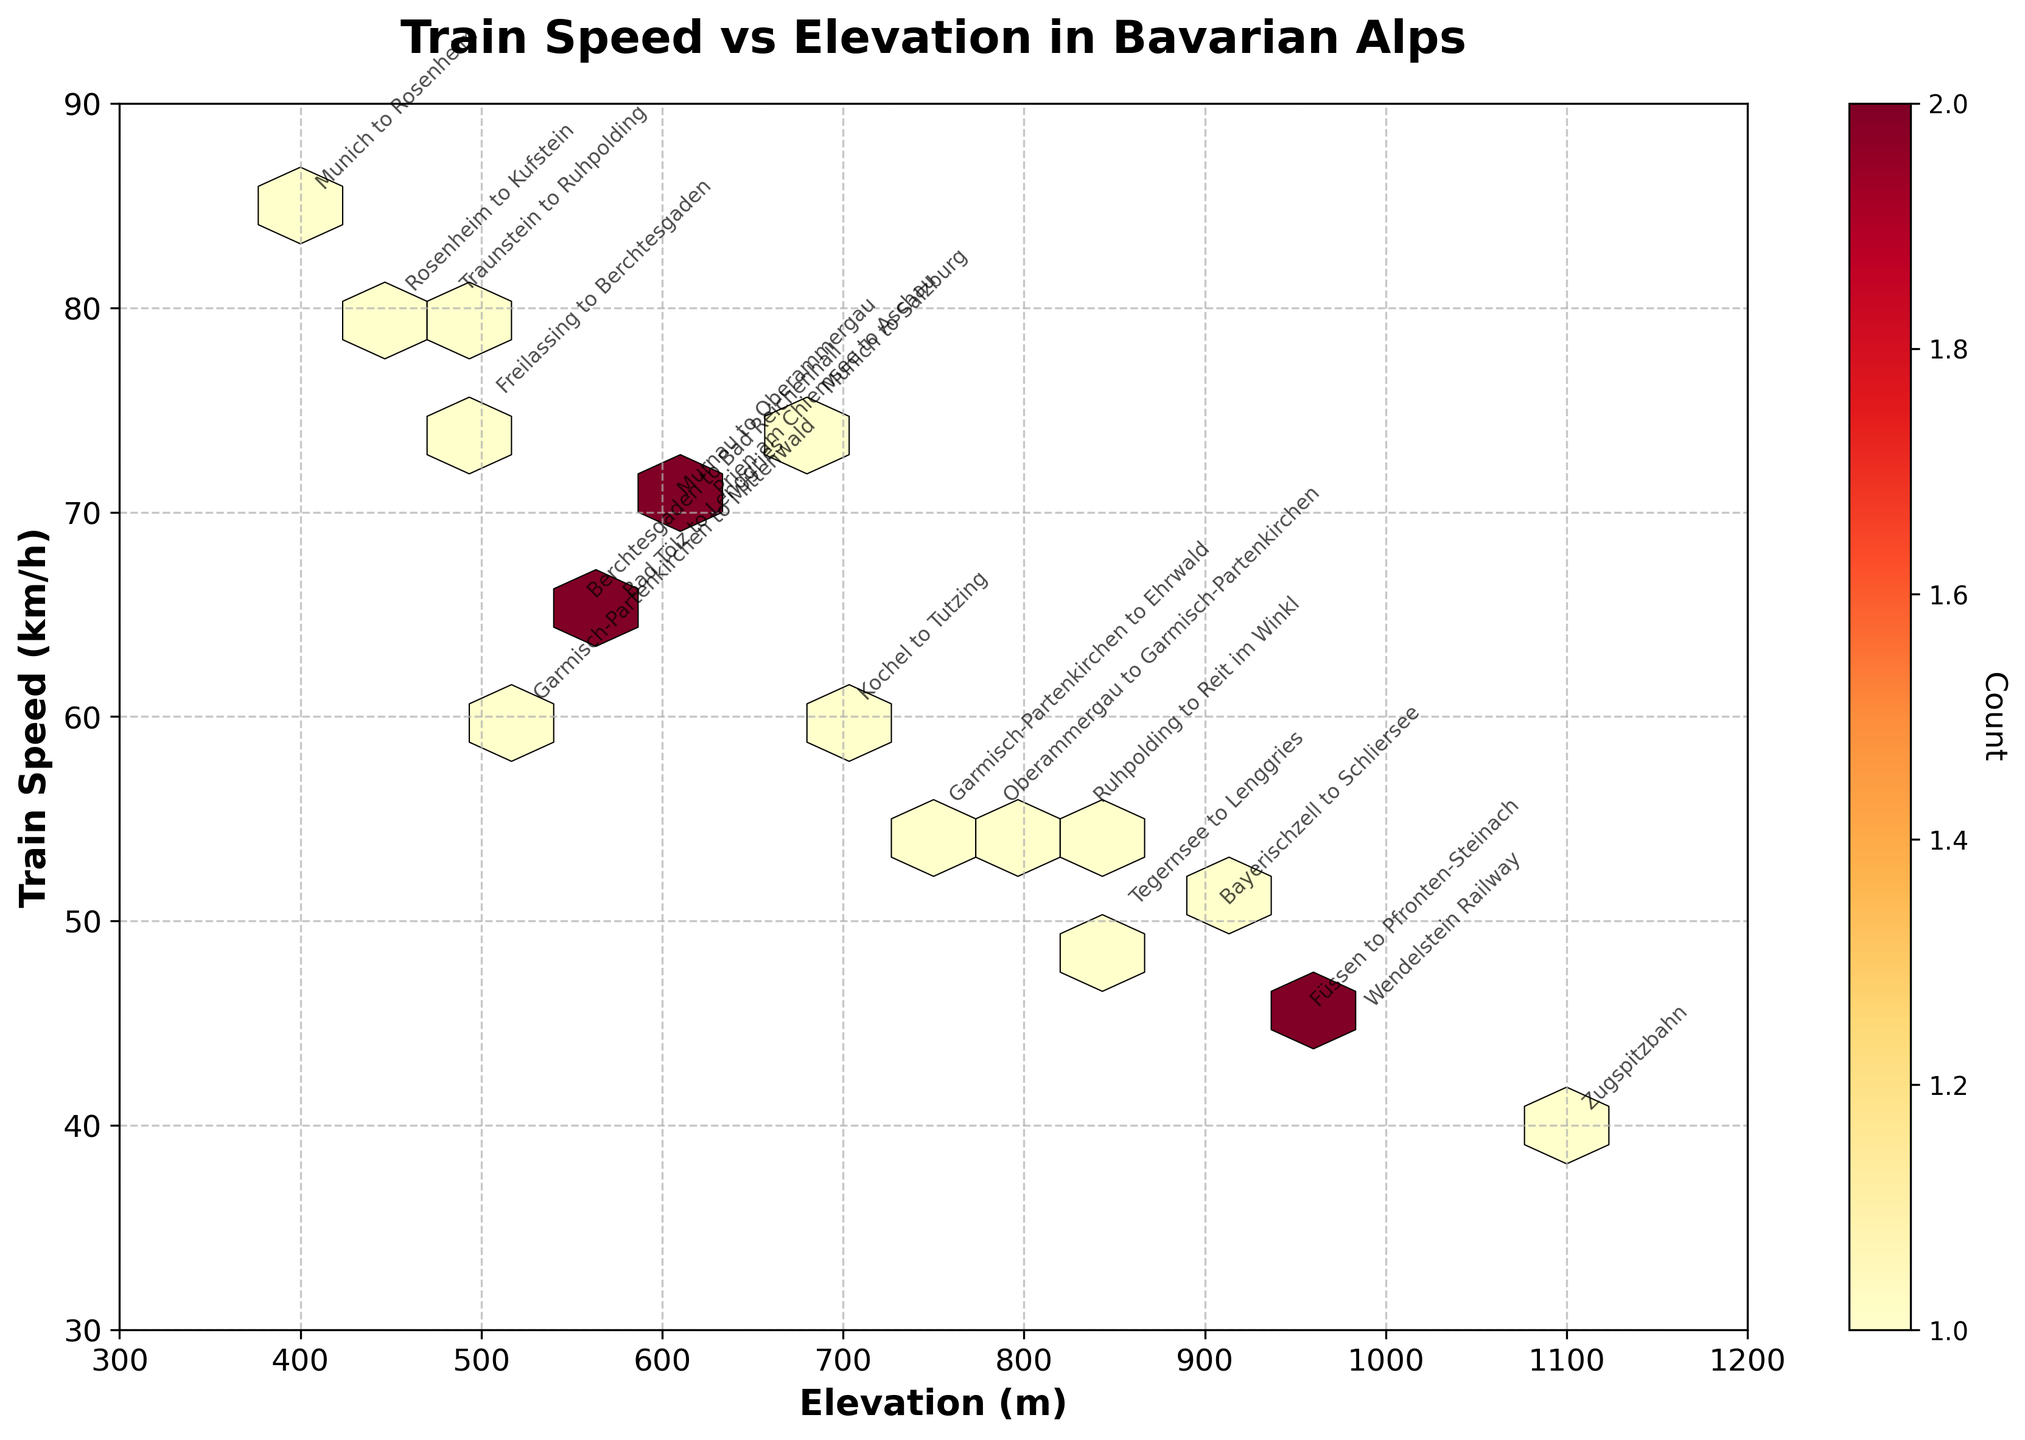What is the title of the Hexbin Plot? The title of a plot is typically displayed at the top, clearly indicating the subject of the visualization. In this case, the title reads "Train Speed vs Elevation in Bavarian Alps".
Answer: Train Speed vs Elevation in Bavarian Alps What are the labels of the axes? The x-axis and y-axis labels describe what each axis represents. The x-axis label is "Elevation (m)", and the y-axis label is "Train Speed (km/h)".
Answer: Elevation (m), Train Speed (km/h) What color scheme is used in the Hexbin Plot? The Hexbin Plot uses a color scheme that ranges from yellow to red. This is indicated by the 'YlOrRd' color map, which stands for "Yellow-Orange-Red". Lighter colors represent lower counts, and darker colors represent higher counts within the hexagons.
Answer: Yellow-Orange-Red (YlOrRd) Which hexagon color represents the highest frequency of data points, and what does it signify? Darker hexagons represent higher frequencies. In the plot, the darker shades of red indicate areas where many data points are clustered, signifying that multiple train routes share similar elevations and speeds.
Answer: Dark red Which train route is at the lowest elevation, and what is that elevation? The "Munich to Rosenheim" route is at the lowest elevation. It's annotated near an elevation of approximately 400 meters.
Answer: Munich to Rosenheim, 400 meters Which route has the steepest climb based on the highest elevation in the plot? The "Zugspitzbahn" route is annotated at roughly 1100 meters elevation. This route has the highest elevation among the plotted routes.
Answer: Zugspitzbahn Is there a common elevation range where most train speeds are clustered? By observing the density of the hexagons, the majority of train speeds seem clustered in the 500-800 meters elevation range.
Answer: 500-800 meters Which train route has the slowest speed, and what is that speed? The "Zugspitzbahn" route also has the lowest speed, annotated around 40 km/h.
Answer: Zugspitzbahn, 40 km/h Compare the train speeds of the "Berchtesgaden to Bad Reichenhall" and "Munich to Salzburg" routes. Which one is faster? By locating the annotations, "Munich to Salzburg" has a speed of 75 km/h, whereas "Berchtesgaden to Bad Reichenhall" has a speed of 65 km/h. Hence, "Munich to Salzburg" is faster.
Answer: Munich to Salzburg 